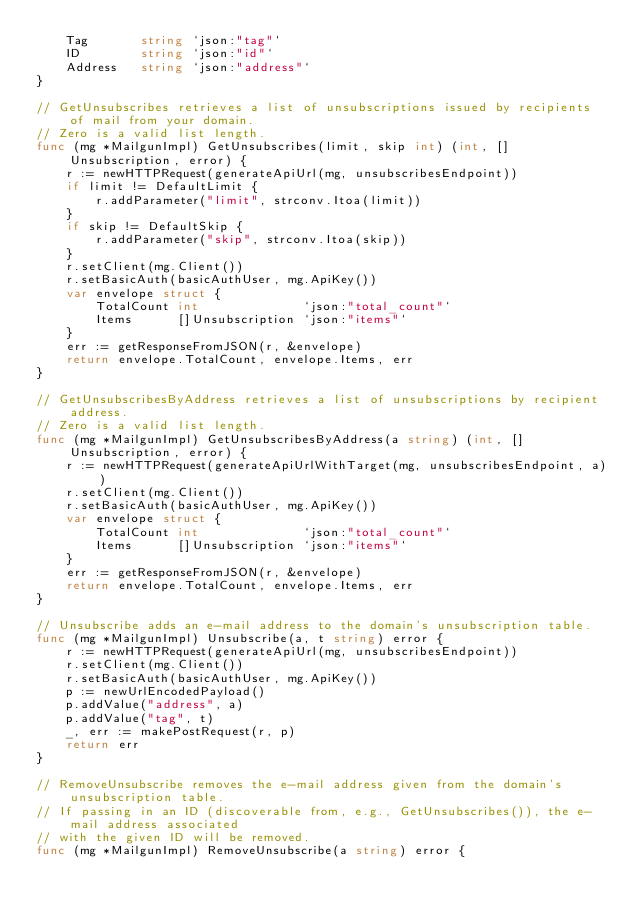Convert code to text. <code><loc_0><loc_0><loc_500><loc_500><_Go_>	Tag       string `json:"tag"`
	ID        string `json:"id"`
	Address   string `json:"address"`
}

// GetUnsubscribes retrieves a list of unsubscriptions issued by recipients of mail from your domain.
// Zero is a valid list length.
func (mg *MailgunImpl) GetUnsubscribes(limit, skip int) (int, []Unsubscription, error) {
	r := newHTTPRequest(generateApiUrl(mg, unsubscribesEndpoint))
	if limit != DefaultLimit {
		r.addParameter("limit", strconv.Itoa(limit))
	}
	if skip != DefaultSkip {
		r.addParameter("skip", strconv.Itoa(skip))
	}
	r.setClient(mg.Client())
	r.setBasicAuth(basicAuthUser, mg.ApiKey())
	var envelope struct {
		TotalCount int              `json:"total_count"`
		Items      []Unsubscription `json:"items"`
	}
	err := getResponseFromJSON(r, &envelope)
	return envelope.TotalCount, envelope.Items, err
}

// GetUnsubscribesByAddress retrieves a list of unsubscriptions by recipient address.
// Zero is a valid list length.
func (mg *MailgunImpl) GetUnsubscribesByAddress(a string) (int, []Unsubscription, error) {
	r := newHTTPRequest(generateApiUrlWithTarget(mg, unsubscribesEndpoint, a))
	r.setClient(mg.Client())
	r.setBasicAuth(basicAuthUser, mg.ApiKey())
	var envelope struct {
		TotalCount int              `json:"total_count"`
		Items      []Unsubscription `json:"items"`
	}
	err := getResponseFromJSON(r, &envelope)
	return envelope.TotalCount, envelope.Items, err
}

// Unsubscribe adds an e-mail address to the domain's unsubscription table.
func (mg *MailgunImpl) Unsubscribe(a, t string) error {
	r := newHTTPRequest(generateApiUrl(mg, unsubscribesEndpoint))
	r.setClient(mg.Client())
	r.setBasicAuth(basicAuthUser, mg.ApiKey())
	p := newUrlEncodedPayload()
	p.addValue("address", a)
	p.addValue("tag", t)
	_, err := makePostRequest(r, p)
	return err
}

// RemoveUnsubscribe removes the e-mail address given from the domain's unsubscription table.
// If passing in an ID (discoverable from, e.g., GetUnsubscribes()), the e-mail address associated
// with the given ID will be removed.
func (mg *MailgunImpl) RemoveUnsubscribe(a string) error {</code> 